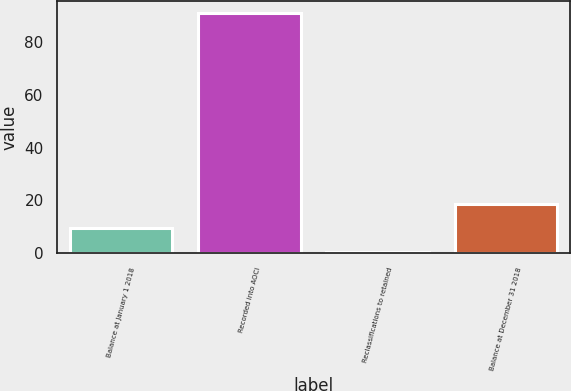Convert chart to OTSL. <chart><loc_0><loc_0><loc_500><loc_500><bar_chart><fcel>Balance at January 1 2018<fcel>Recorded into AOCI<fcel>Reclassifications to retained<fcel>Balance at December 31 2018<nl><fcel>9.45<fcel>90.9<fcel>0.4<fcel>18.5<nl></chart> 